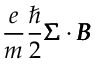Convert formula to latex. <formula><loc_0><loc_0><loc_500><loc_500>\frac { e } { m } \frac { } { 2 } \pm b { \Sigma } \cdot \pm b { B }</formula> 